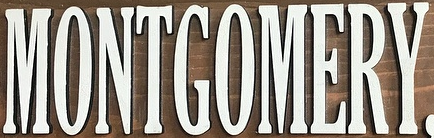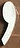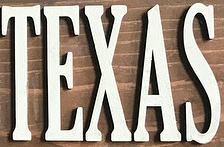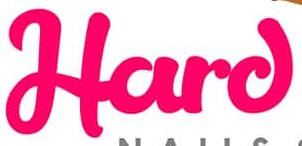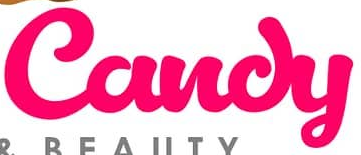Read the text from these images in sequence, separated by a semicolon. MONTGOMERY; ,; TEXAS; Hard; Candy 